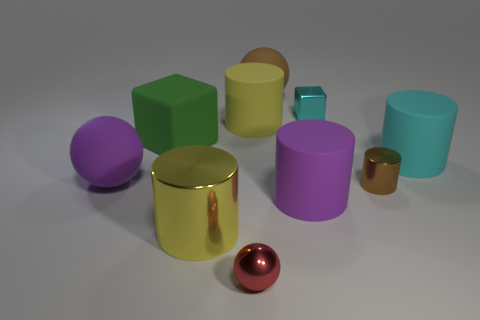There is a metallic cylinder behind the large purple matte cylinder; does it have the same color as the tiny metallic sphere?
Offer a terse response. No. How many other objects are the same material as the tiny red object?
Ensure brevity in your answer.  3. Is the color of the small cylinder the same as the tiny ball?
Provide a short and direct response. No. Does the tiny brown object have the same shape as the large purple matte object that is left of the purple cylinder?
Ensure brevity in your answer.  No. What number of things are small metal objects behind the big rubber cube or large objects in front of the yellow rubber cylinder?
Provide a short and direct response. 6. Are there fewer big purple cylinders that are on the left side of the big brown thing than big green spheres?
Provide a succinct answer. No. Does the large green block have the same material as the object behind the tiny cyan cube?
Make the answer very short. Yes. What material is the red ball?
Ensure brevity in your answer.  Metal. There is a cube that is right of the large yellow cylinder that is behind the rubber ball that is on the left side of the yellow rubber object; what is it made of?
Your response must be concise. Metal. There is a big metallic object; is its color the same as the ball behind the cyan rubber thing?
Make the answer very short. No. 